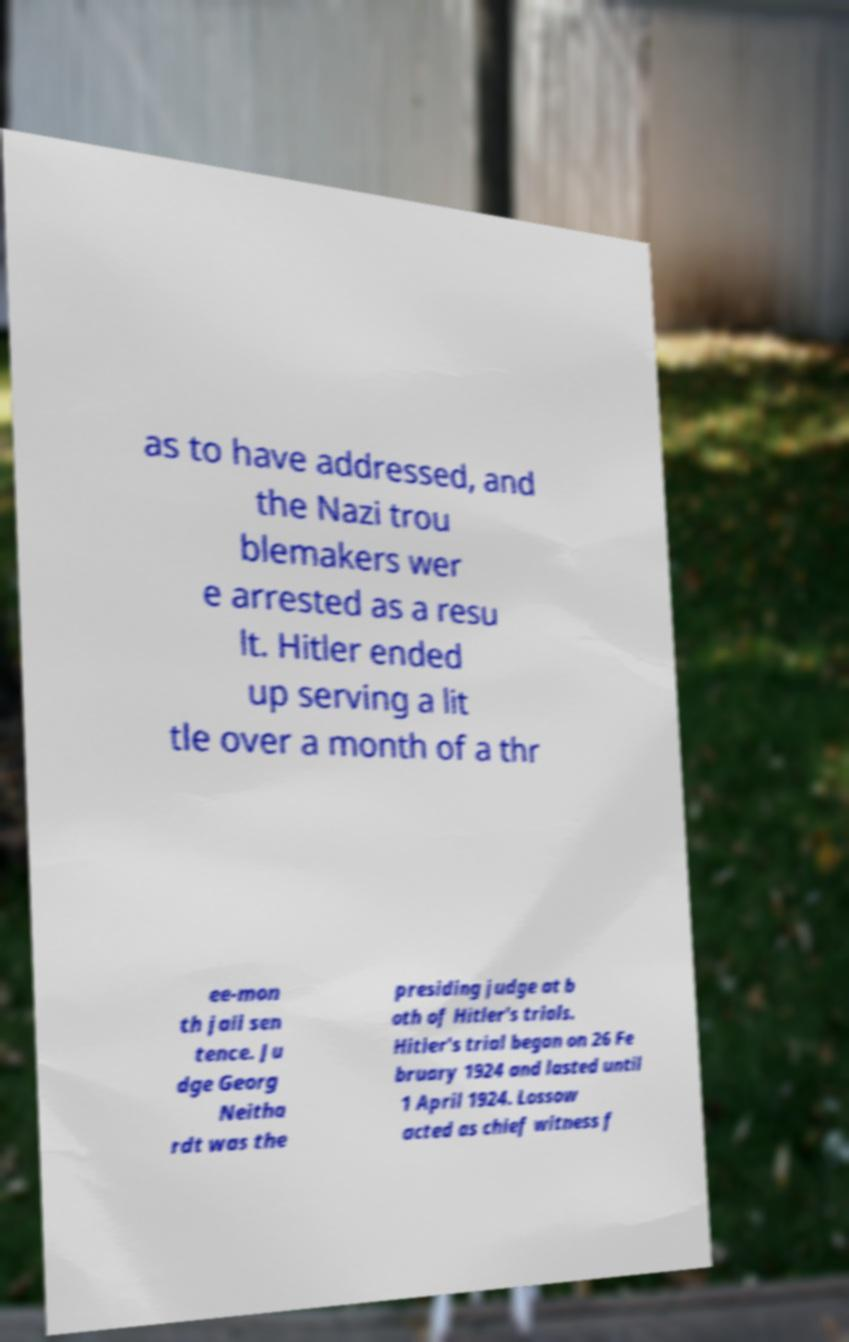Can you read and provide the text displayed in the image?This photo seems to have some interesting text. Can you extract and type it out for me? as to have addressed, and the Nazi trou blemakers wer e arrested as a resu lt. Hitler ended up serving a lit tle over a month of a thr ee-mon th jail sen tence. Ju dge Georg Neitha rdt was the presiding judge at b oth of Hitler's trials. Hitler's trial began on 26 Fe bruary 1924 and lasted until 1 April 1924. Lossow acted as chief witness f 